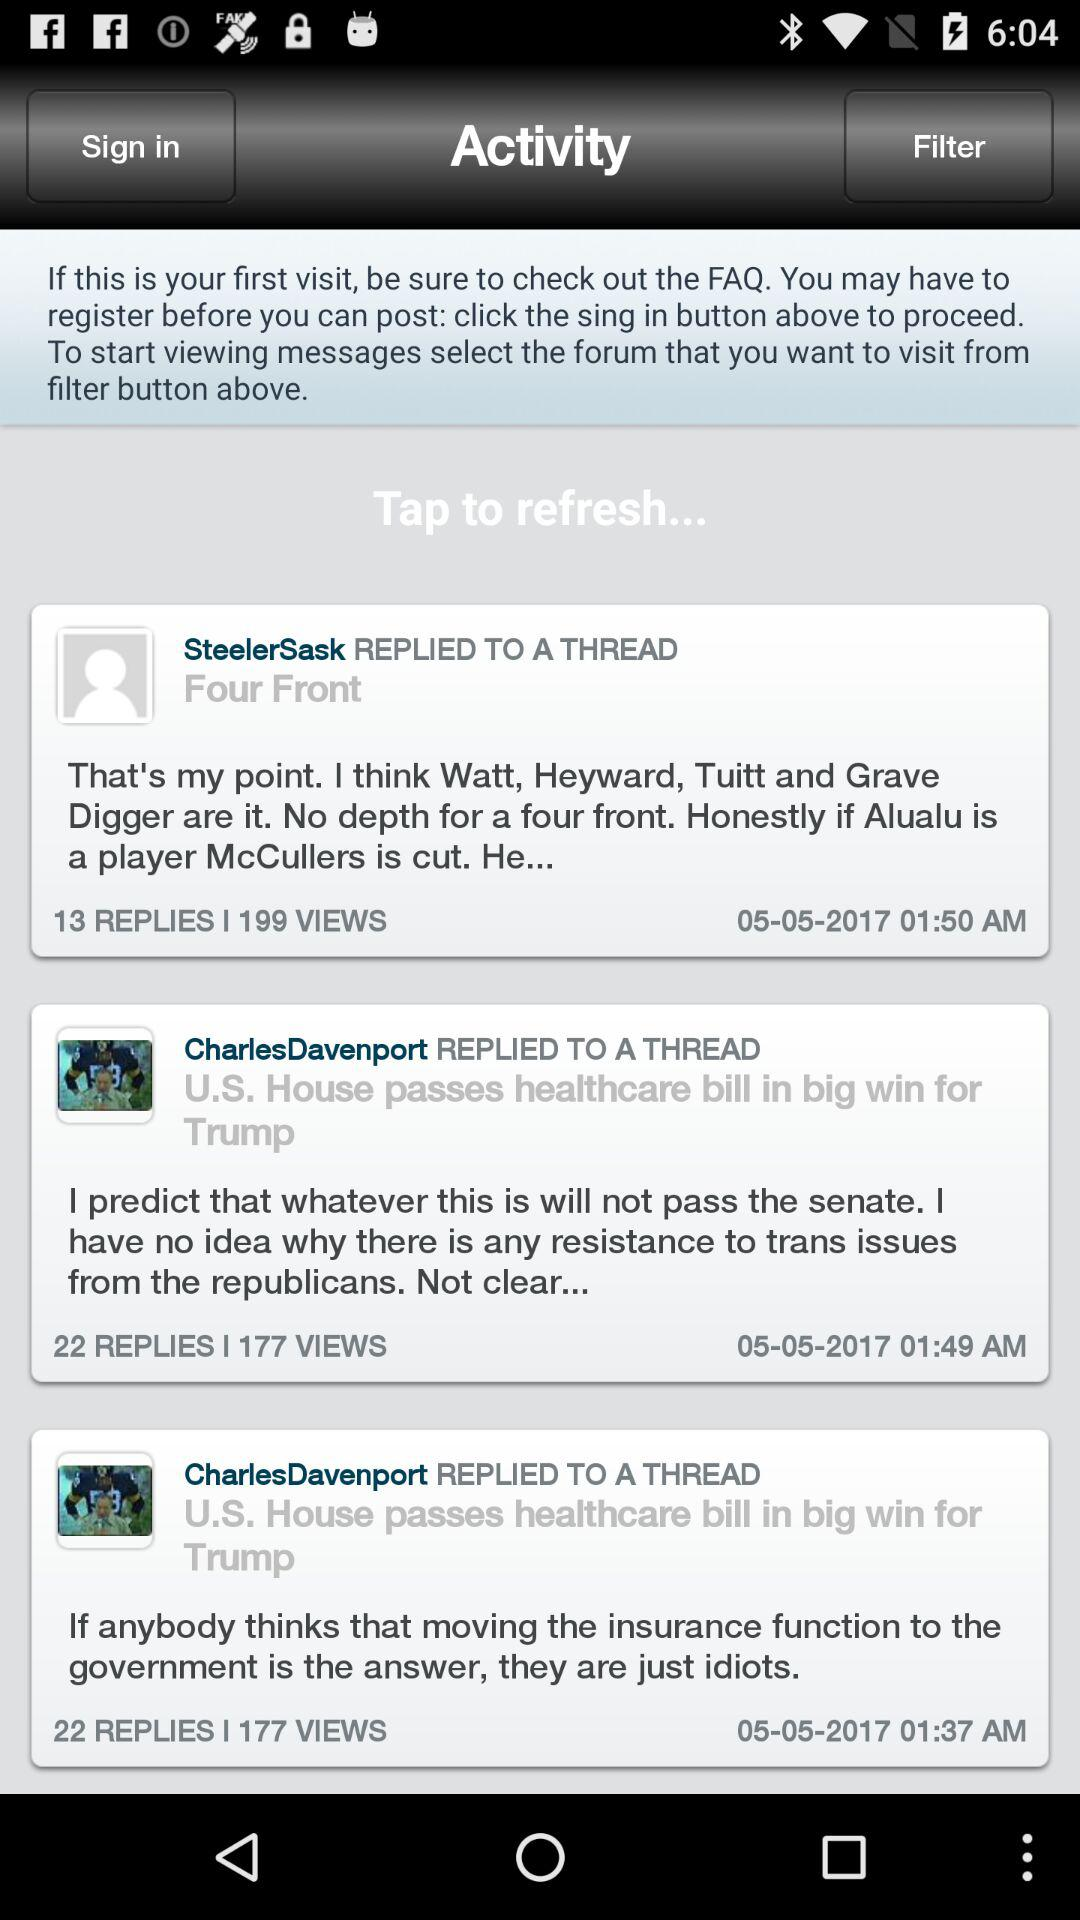How many views on SteelerSask's post? There are 199 views on SteelerSask's post. 